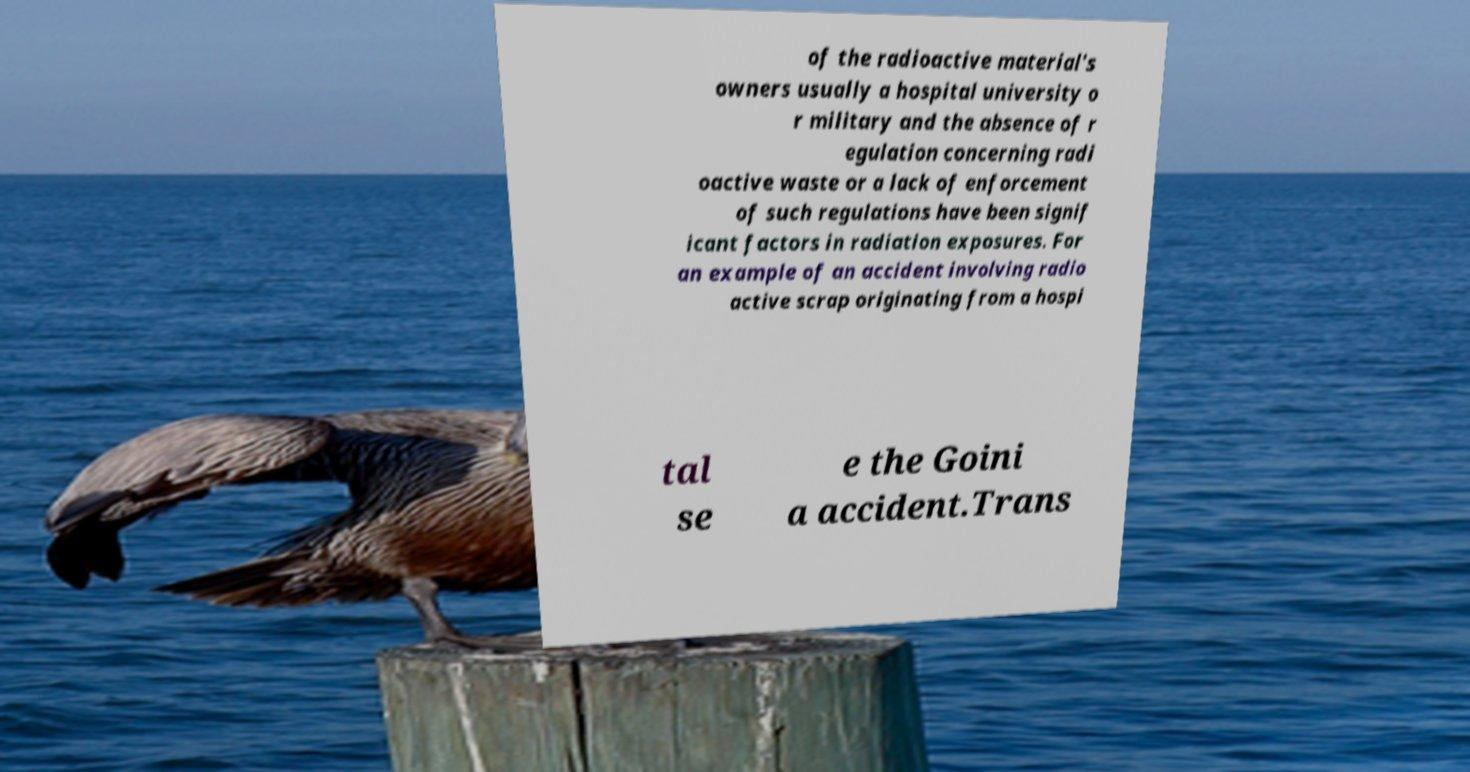Please identify and transcribe the text found in this image. of the radioactive material's owners usually a hospital university o r military and the absence of r egulation concerning radi oactive waste or a lack of enforcement of such regulations have been signif icant factors in radiation exposures. For an example of an accident involving radio active scrap originating from a hospi tal se e the Goini a accident.Trans 